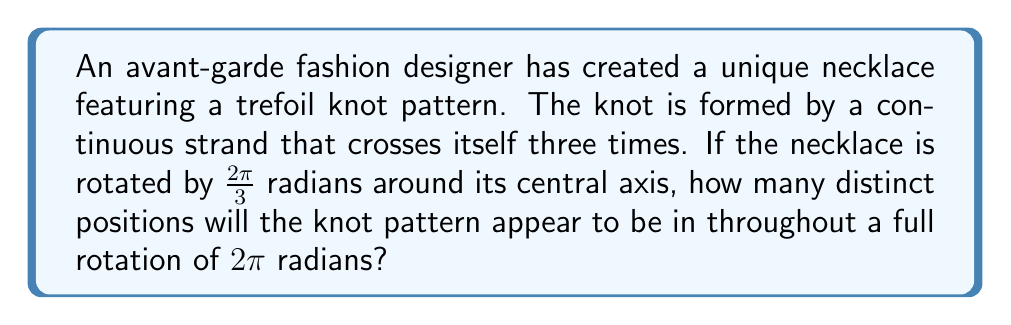Give your solution to this math problem. To solve this problem, we need to analyze the rotational symmetry of the trefoil knot:

1. The trefoil knot has a 3-fold rotational symmetry, meaning it looks the same after rotations of $\frac{2\pi}{3}$ radians (120°).

2. To find the number of distinct positions, we need to determine how many times we can rotate by $\frac{2\pi}{3}$ before returning to the original position:

   $$\text{Number of positions} = \frac{\text{Full rotation}}{\text{Symmetry rotation}}$$

3. Substituting the values:

   $$\text{Number of positions} = \frac{2\pi}{\frac{2\pi}{3}} = 3$$

4. This means that as we rotate the necklace through a full $2\pi$ radians, we will see the knot pattern in 3 distinct positions before it returns to its original orientation.

5. These positions occur at rotations of 0, $\frac{2\pi}{3}$, and $\frac{4\pi}{3}$ radians.

[asy]
import geometry;

size(200);

path trefoil = (2,0)..(0,2)..(-2,0)..(0,-2)..cycle;
trefoil = rotate(60)*trefoil;

draw(trefoil, linewidth(2));
draw(rotate(120)*trefoil, linewidth(2)+dashed);
draw(rotate(240)*trefoil, linewidth(2)+dotted);

label("0", (2.5,0), E);
label("$\frac{2\pi}{3}$", rotate(120)*(2.5,0), N);
label("$\frac{4\pi}{3}$", rotate(240)*(2.5,0), W);
[/asy]
Answer: 3 distinct positions 